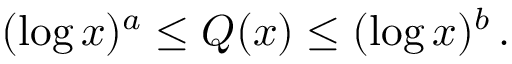<formula> <loc_0><loc_0><loc_500><loc_500>( \log x ) ^ { a } \leq Q ( x ) \leq ( \log x ) ^ { b } \, .</formula> 